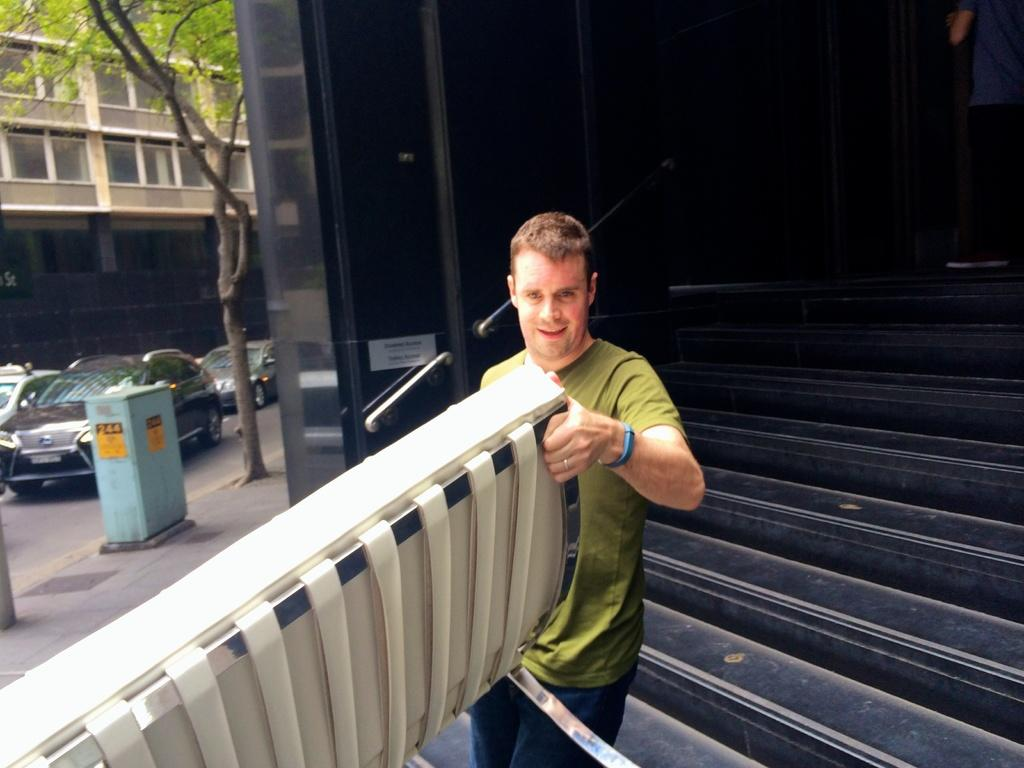What is the man in the image doing? The man is standing in the image. What is the man holding in the image? The man is holding an object. Can you describe the architectural feature in the image? There are stairs and a railing present in the image. What type of structure is visible in the image? There is a building in the image. What natural element can be seen in the image? There is a tree in the image. What can be seen on the road in the image? Cars are visible on the road in the image. What type of hat is the man wearing in the image? There is no hat visible on the man in the image. What kind of marble is the man playing with in the image? There is no marble present in the image; the man is holding an object, but it is not specified as a marble. 